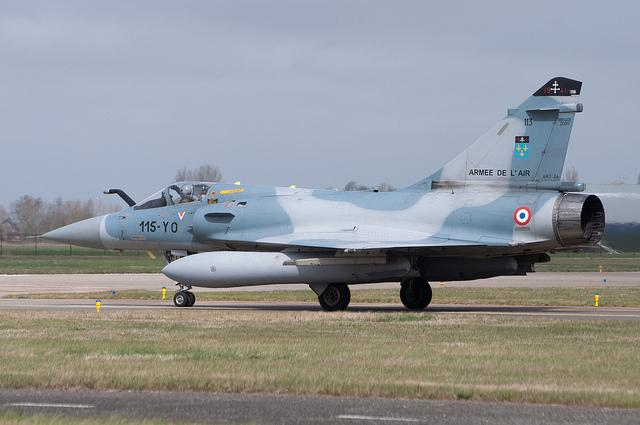What country does this plane belong to?

Choices:
A) uganda
B) france
C) poland
D) canada france 